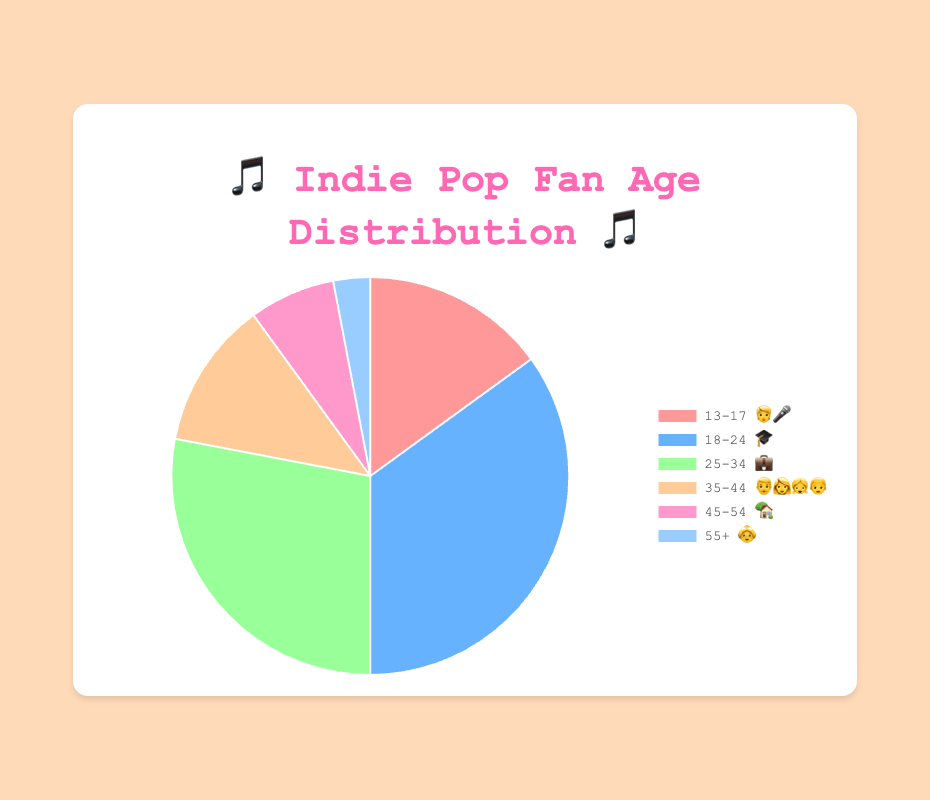Which age group has the highest percentage of fans? The age group with the highest percentage is indicated by the largest slice in the pie chart. The "18-24 🎓" group has a percentage of 35%, making it the highest.
Answer: 18-24 🎓 Which age group has the lowest percentage of fans? The age group with the lowest percentage is indicated by the smallest slice in the pie chart. The "55+ 👵" group has a percentage of 3%, making it the lowest.
Answer: 55+ 👵 What is the total percentage of fans in the 25-34 💼 and 35-44 👨‍👩‍👧‍👦 age groups? To find the total percentage, simply add the percentages for the two age groups. The "25-34 💼" group has 28%, and the "35-44 👨‍👩‍👧‍👦" group has 12%. Adding them gives 28% + 12% = 40%.
Answer: 40% By how much does the percentage of the 18-24 🎓 group exceed the 13-17 🧑‍🎤 group? To find how much one group's percentage exceeds another, subtract the smaller percentage from the larger one. The "18-24 🎓" group has 35%, and the "13-17 🧑‍🎤" group has 15%. Subtracting gives 35% - 15% = 20%.
Answer: 20% What is the average percentage of fans across all age groups? To find the average percentage, sum up all the percentages and divide by the number of age groups. The percentages are 15%, 35%, 28%, 12%, 7%, and 3%, summing up to 100%. Dividing by 6 gives 100% / 6 ≈ 16.67%.
Answer: 16.67% Which two age groups have the closest percentages? To determine the closest percentages, compare the differences between each pair of age groups. The smallest difference is between the "25-34 💼" group (28%) and the "35-44 👨‍👩‍👧‍👦" group (12%), with a difference of 28% - 12% = 16%.
Answer: 25-34 💼 and 35-44 👨‍👩‍👧‍👦 How many age groups have a percentage higher than 10%? Count the number of age groups with percentages greater than 10%. The age groups "13-17 🧑‍🎤" (15%), "18-24 🎓" (35%), "25-34 💼" (28%), and "35-44 👨‍👩‍👧‍👦" (12%) each exceed 10%. There are 4 such groups.
Answer: 4 